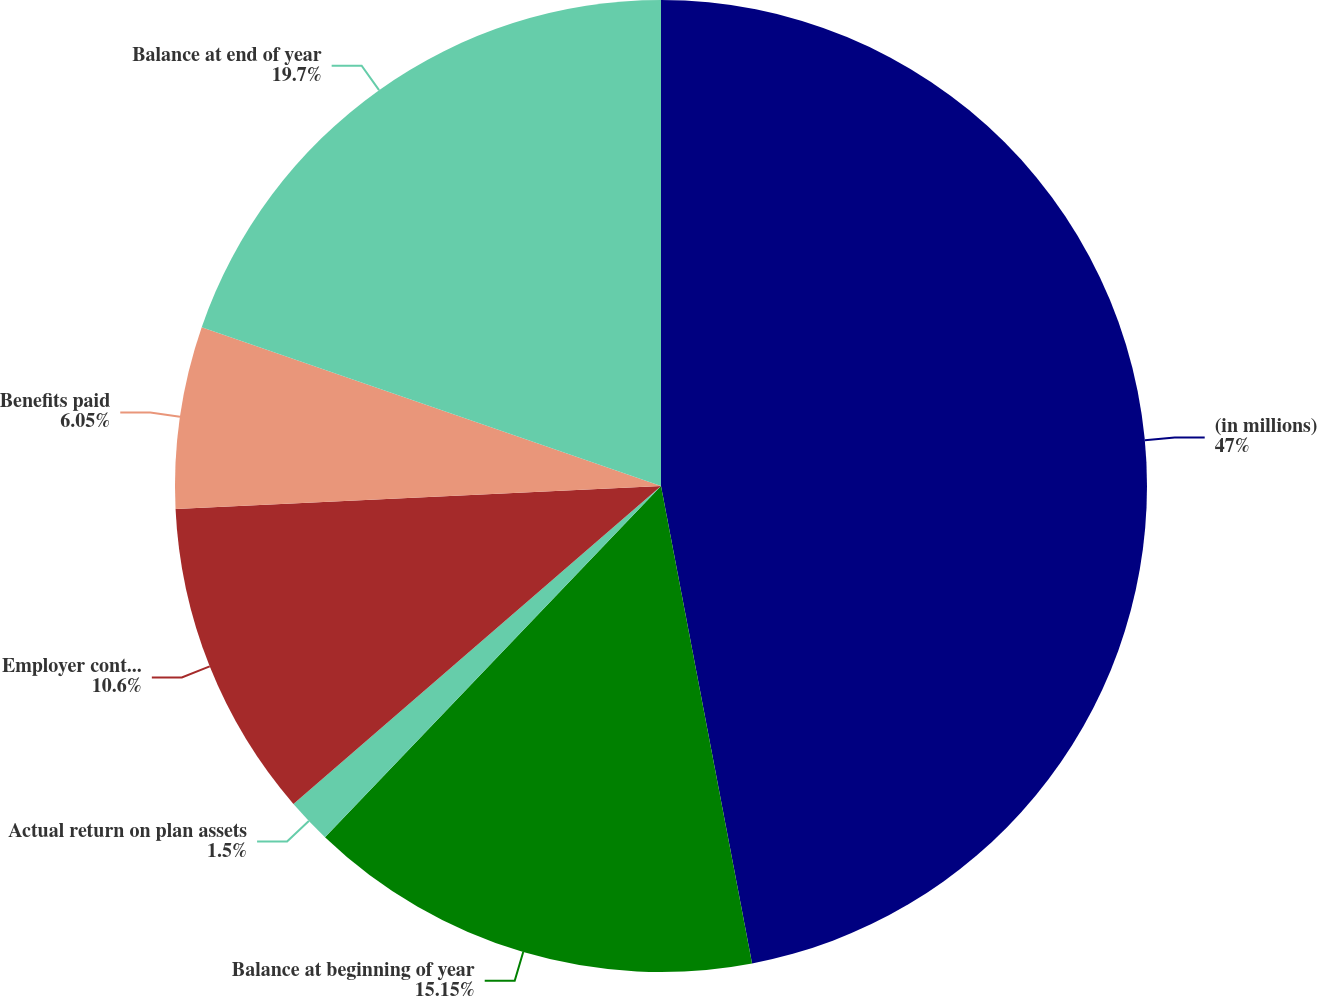Convert chart. <chart><loc_0><loc_0><loc_500><loc_500><pie_chart><fcel>(in millions)<fcel>Balance at beginning of year<fcel>Actual return on plan assets<fcel>Employer contributions<fcel>Benefits paid<fcel>Balance at end of year<nl><fcel>47.0%<fcel>15.15%<fcel>1.5%<fcel>10.6%<fcel>6.05%<fcel>19.7%<nl></chart> 